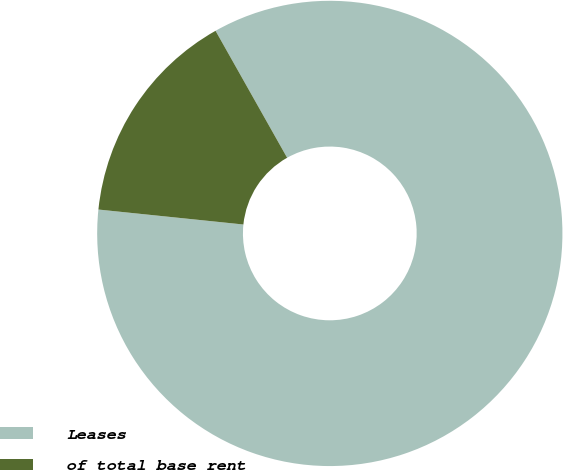Convert chart. <chart><loc_0><loc_0><loc_500><loc_500><pie_chart><fcel>Leases<fcel>of total base rent<nl><fcel>84.81%<fcel>15.19%<nl></chart> 